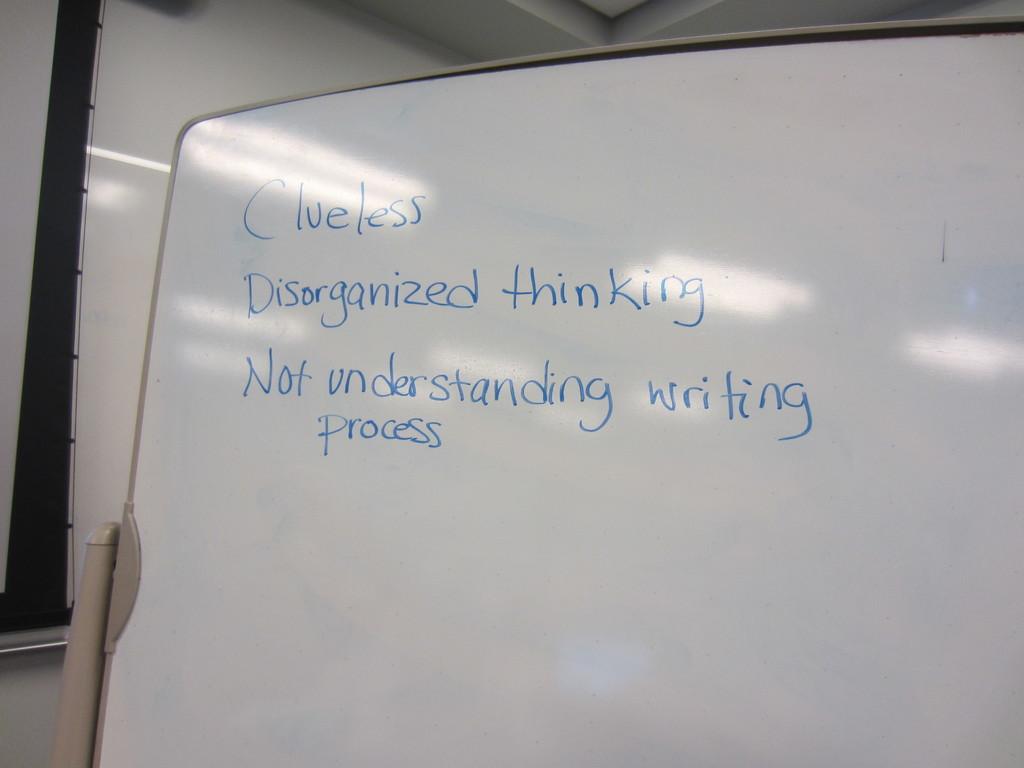What is not being understood?
Give a very brief answer. Writing process. What type of thinking is listed?
Ensure brevity in your answer.  Disorganized. 